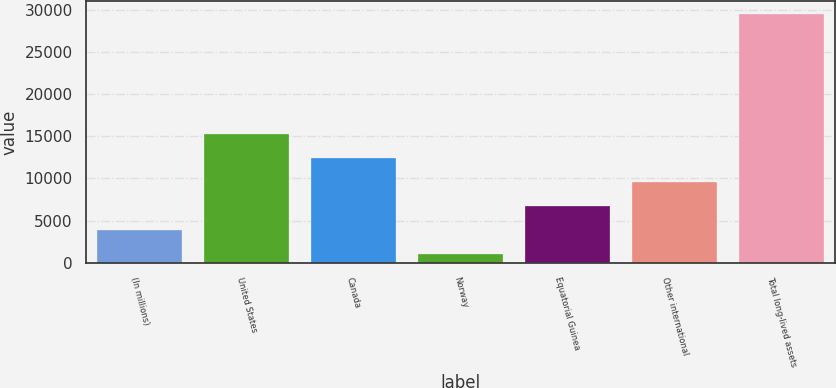<chart> <loc_0><loc_0><loc_500><loc_500><bar_chart><fcel>(In millions)<fcel>United States<fcel>Canada<fcel>Norway<fcel>Equatorial Guinea<fcel>Other international<fcel>Total long-lived assets<nl><fcel>3843.4<fcel>15269<fcel>12412.6<fcel>987<fcel>6699.8<fcel>9556.2<fcel>29551<nl></chart> 